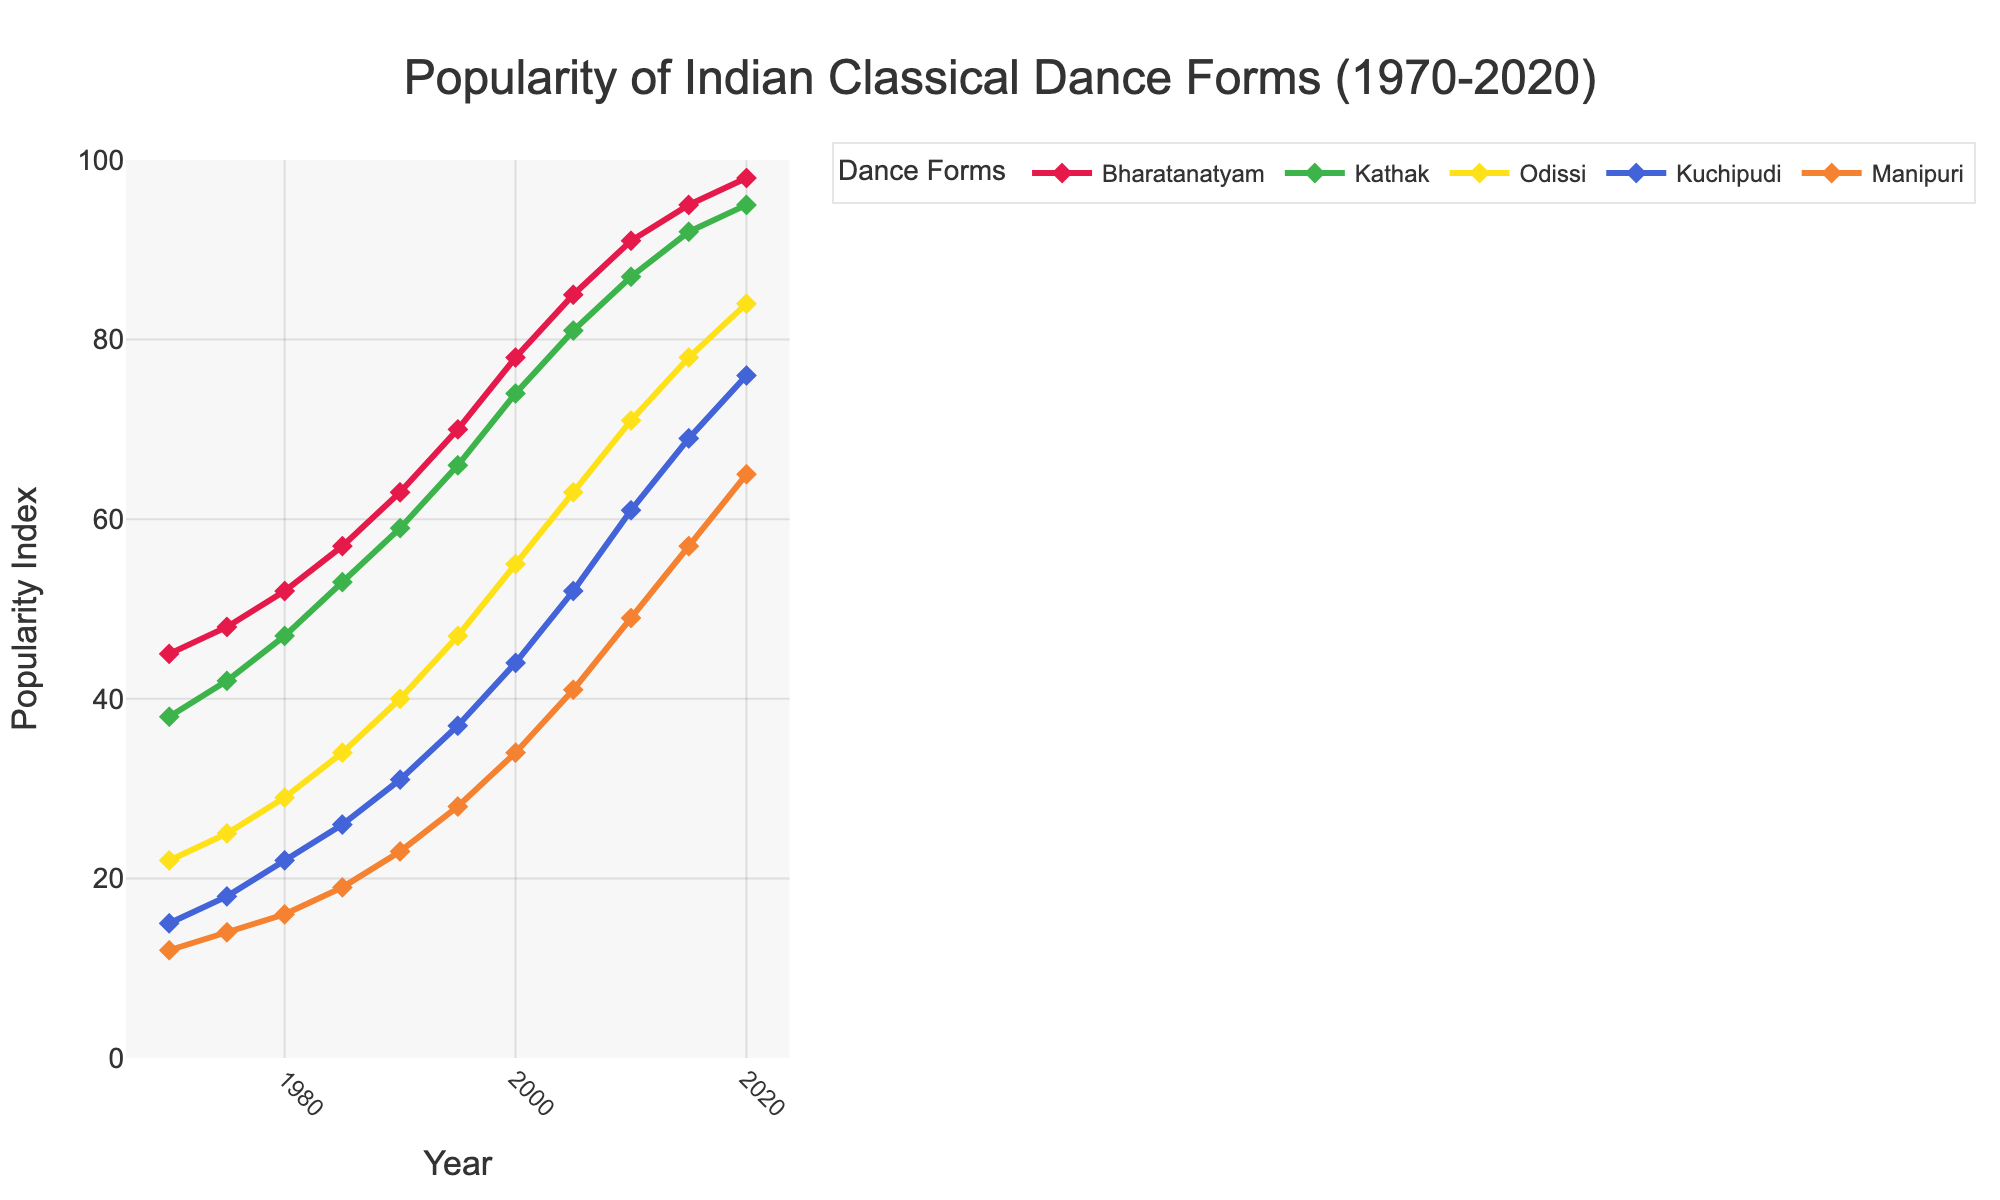Which dance form had the highest popularity index in 2020? The graph shows the popularity trends of Indian classical dance forms over 50 years. In 2020, Bharatanatyam had the highest popularity index.
Answer: Bharatanatyam Between 1980 and 1990, which dance form saw the biggest increase in popularity index? By subtracting the 1980 values from the 1990 values for each dance form, we see that Bharatanatyam increased from 52 to 63, Kathak from 47 to 59, Odissi from 29 to 40, Kuchipudi from 22 to 31, and Manipuri from 16 to 23. Clearly, Kathak saw the biggest increase.
Answer: Kathak What was the average popularity index for Odissi in the 1980s? The values for Odissi in the 1980s are 29, 34, and 40. To find the average, we sum these values (29 + 34 + 40 = 103) and divide by the number of data points (3), resulting in approximately 34.3.
Answer: 34.3 How much did the popularity index for Manipuri change from 1970 to 2020? In 1970, the popularity index for Manipuri was 12, and in 2020 it was 65. Subtracting the 1970 value from the 2020 value gives 65 - 12 = 53.
Answer: 53 Which dance forms had a similar popularity index in the year 2000? In 2000, Bharatanatyam had a popularity index of 78, Kathak of 74, and Odissi of 55, while Kuchipudi had 44 and Manipuri 34. Odissi and Kuchipudi had the closest values (55 and 44).
Answer: Odissi and Kuchipudi In which decade did Kuchipudi surpass Manipuri in popularity? By examining the graph, we see that until 1980, Manipuri had higher or equal values compared to Kuchipudi, but from 1985 onwards, Kuchipudi's popularity index surpasses that of Manipuri.
Answer: 1980s By how much did the popularity index of Bharatanatyam increase between 1970 and 2010? In 1970, Bharatanatyam's popularity index was 45, and by 2010 it was 91. By subtracting these values, we find the increase: 91 - 45 = 46.
Answer: 46 Which year did Kathak's popularity index exceed 50? The graph shows that Kathak's popularity index exceeded 50 in the year 1985.
Answer: 1985 Comparing Odissi and Kathak, which dance form saw a more consistent increase in popularity index over time? By inspecting the line patterns, we notice that Kathak consistently increased without dips over the years, signifying a more consistent increase compared to Odissi.
Answer: Kathak 